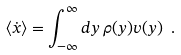<formula> <loc_0><loc_0><loc_500><loc_500>\langle \dot { x } \rangle = \int _ { - \infty } ^ { \infty } d y \, \rho ( y ) v ( y ) \ .</formula> 